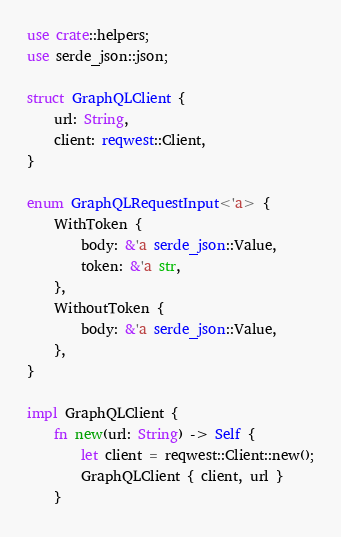<code> <loc_0><loc_0><loc_500><loc_500><_Rust_>use crate::helpers;
use serde_json::json;

struct GraphQLClient {
    url: String,
    client: reqwest::Client,
}

enum GraphQLRequestInput<'a> {
    WithToken {
        body: &'a serde_json::Value,
        token: &'a str,
    },
    WithoutToken {
        body: &'a serde_json::Value,
    },
}

impl GraphQLClient {
    fn new(url: String) -> Self {
        let client = reqwest::Client::new();
        GraphQLClient { client, url }
    }
</code> 